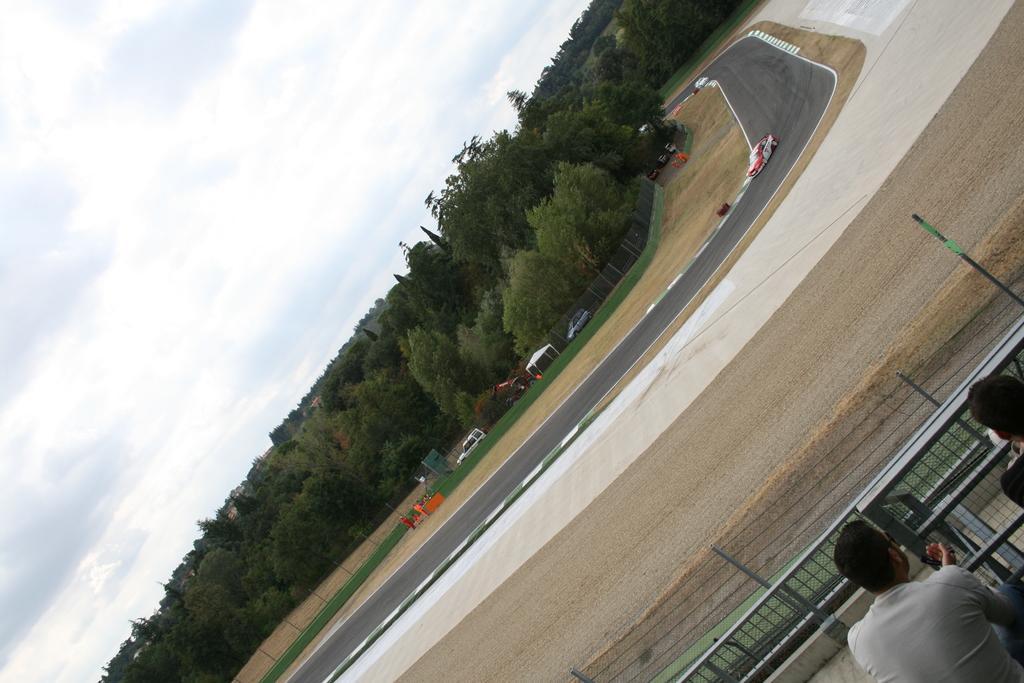Could you give a brief overview of what you see in this image? In this image, I can see a car on the road. At the bottom right corner of the image, there are two people and iron grilles. I can see trees, tent, two cars, fence and few people. In the background, there is the sky. 